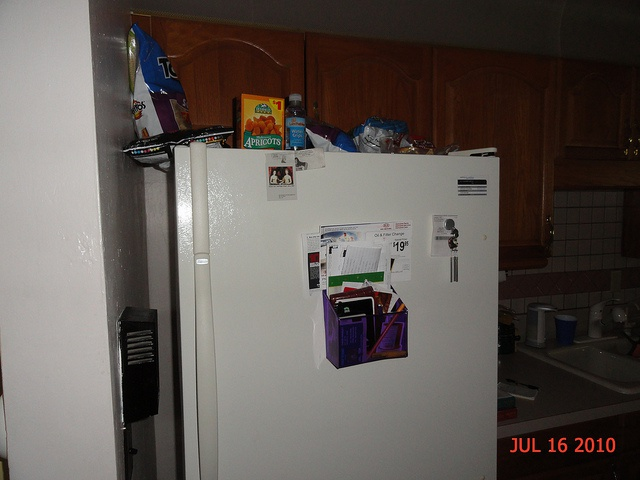Describe the objects in this image and their specific colors. I can see refrigerator in gray, darkgray, and black tones, cup in black and gray tones, bottle in gray, black, blue, and darkblue tones, book in gray, black, and darkgray tones, and bowl in black and gray tones in this image. 